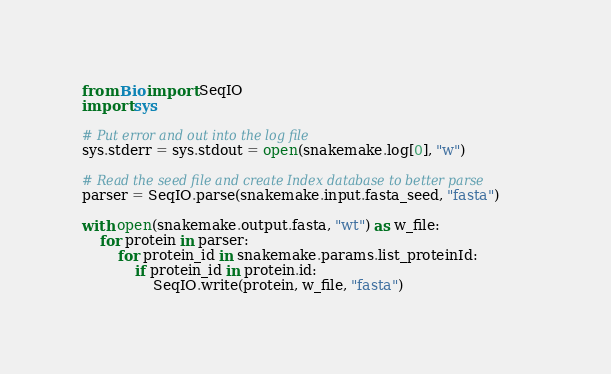<code> <loc_0><loc_0><loc_500><loc_500><_Python_>from Bio import SeqIO
import sys

# Put error and out into the log file
sys.stderr = sys.stdout = open(snakemake.log[0], "w")

# Read the seed file and create Index database to better parse
parser = SeqIO.parse(snakemake.input.fasta_seed, "fasta")

with open(snakemake.output.fasta, "wt") as w_file:
    for protein in parser:
        for protein_id in snakemake.params.list_proteinId:
            if protein_id in protein.id:
                SeqIO.write(protein, w_file, "fasta")</code> 